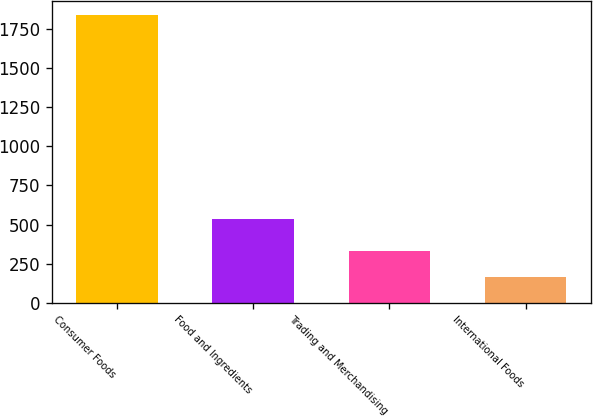Convert chart to OTSL. <chart><loc_0><loc_0><loc_500><loc_500><bar_chart><fcel>Consumer Foods<fcel>Food and Ingredients<fcel>Trading and Merchandising<fcel>International Foods<nl><fcel>1842<fcel>538<fcel>332.7<fcel>165<nl></chart> 